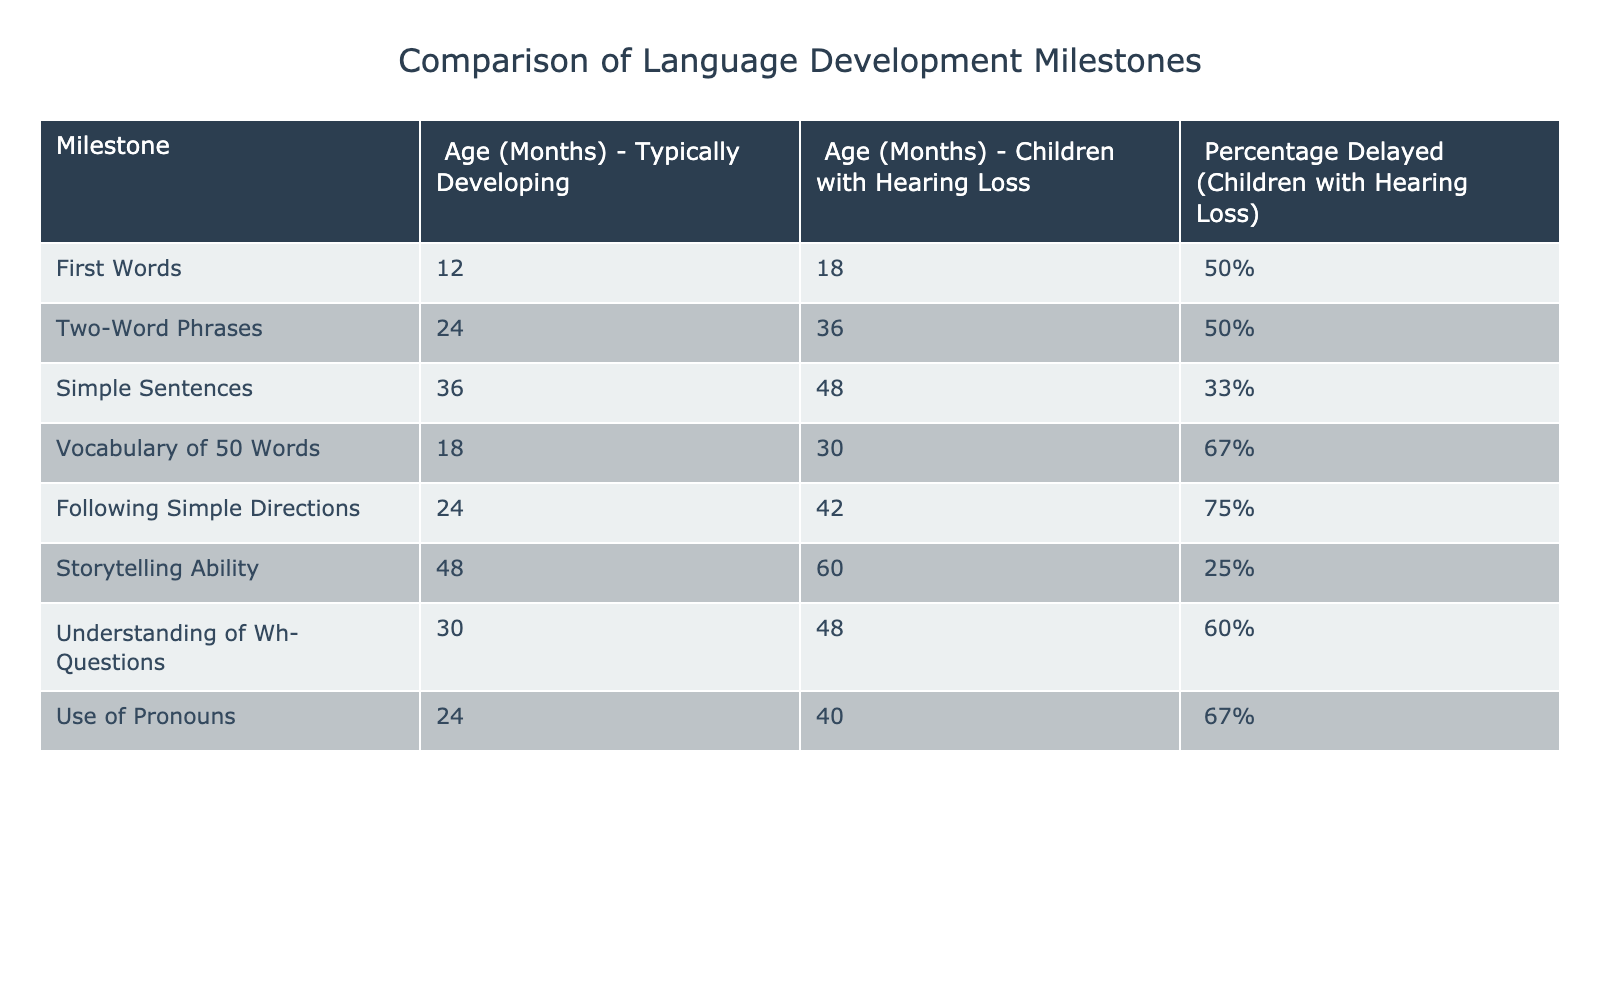What is the age at which typically developing children typically say their first words? According to the table, typically developing children say their first words at 12 months.
Answer: 12 months What is the age at which children with hearing loss typically develop two-word phrases? The table indicates that children with hearing loss typically develop two-word phrases at 36 months.
Answer: 36 months What percentage of children with hearing loss are delayed in following simple directions? The table shows that 75% of children with hearing loss are delayed in following simple directions.
Answer: 75% How many more months does it take for children with hearing loss to reach the milestone of understanding Wh- questions compared to typically developing children? The milestone of understanding Wh- questions is reached at 48 months for children with hearing loss and at 30 months for typically developing children. Therefore, it takes 48 - 30 = 18 more months for children with hearing loss.
Answer: 18 months True or false: Only 0% of children with hearing loss are delayed in storytelling ability. The table reveals that 25% of children with hearing loss are delayed in storytelling ability, which indicates that the statement is false.
Answer: False What is the average percentage of delay for all milestones listed for children with hearing loss? The percentages delayed for children with hearing loss across all milestones are 50%, 50%, 33%, 67%, 75%, 25%, 60%, and 67%. Adding these up gives 50 + 50 + 33 + 67 + 75 + 25 + 60 + 67 = 427. Dividing this sum by 8 gives an average of 53.375%.
Answer: 53.375% Which milestone shows the highest percentage of delay for children with hearing loss? Upon reviewing the percentages in the table, the milestone showing the highest percentage of delay for children with hearing loss is following simple directions, with a delay of 75%.
Answer: Following simple directions What is the difference in age for children developing vocabulary of 50 words between typically developing children and children with hearing loss? Typically developing children reach a vocabulary of 50 words at 18 months, while children with hearing loss reach this milestone at 30 months. The difference is 30 - 18 = 12 months.
Answer: 12 months How many milestones show a delay percentage of 67% or higher for children with hearing loss? Based on the table, the milestones with 67% or higher delay percentages are vocabulary of 50 words (67%), following simple directions (75%), and use of pronouns (67%). This totals three milestones.
Answer: 3 